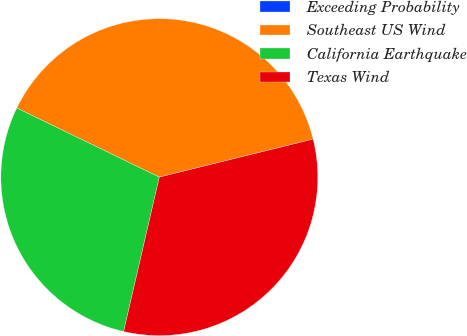Convert chart to OTSL. <chart><loc_0><loc_0><loc_500><loc_500><pie_chart><fcel>Exceeding Probability<fcel>Southeast US Wind<fcel>California Earthquake<fcel>Texas Wind<nl><fcel>0.0%<fcel>38.96%<fcel>28.57%<fcel>32.47%<nl></chart> 